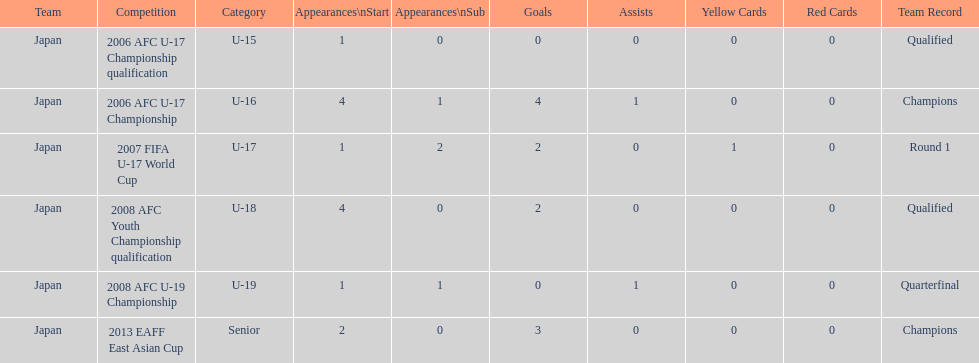Yoichiro kakitani scored above 2 goals in how many major competitions? 2. Would you be able to parse every entry in this table? {'header': ['Team', 'Competition', 'Category', 'Appearances\\nStart', 'Appearances\\nSub', 'Goals', 'Assists', 'Yellow Cards', 'Red Cards', 'Team Record'], 'rows': [['Japan', '2006 AFC U-17 Championship qualification', 'U-15', '1', '0', '0', '0', '0', '0', 'Qualified'], ['Japan', '2006 AFC U-17 Championship', 'U-16', '4', '1', '4', '1', '0', '0', 'Champions'], ['Japan', '2007 FIFA U-17 World Cup', 'U-17', '1', '2', '2', '0', '1', '0', 'Round 1'], ['Japan', '2008 AFC Youth Championship qualification', 'U-18', '4', '0', '2', '0', '0', '0', 'Qualified'], ['Japan', '2008 AFC U-19 Championship', 'U-19', '1', '1', '0', '1', '0', '0', 'Quarterfinal'], ['Japan', '2013 EAFF East Asian Cup', 'Senior', '2', '0', '3', '0', '0', '0', 'Champions']]} 